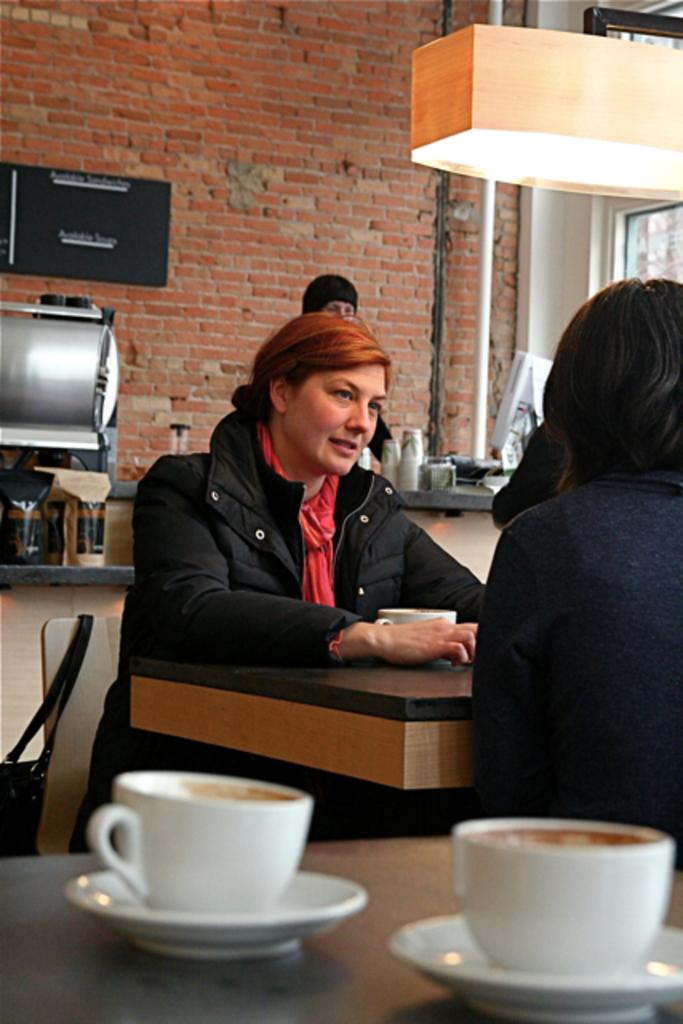What is the person in the image doing? The person is sitting in a chair. What is located near the person? There is a table in the image. What can be seen on the table? There is a cup and saucer on the table. What can be seen on the wall in the background? There is a red wall with bricks visible in the background. What electronic device is present in the background? There is a monitor in the background. What type of cars can be seen in the lunchroom in the image? There are no cars or lunchroom present in the image; it features a person sitting in a chair with a table, cup and saucer, red wall with bricks, and a monitor in the background. What kind of cloud formation is visible through the window in the image? There is no window or cloud formation visible in the image. 